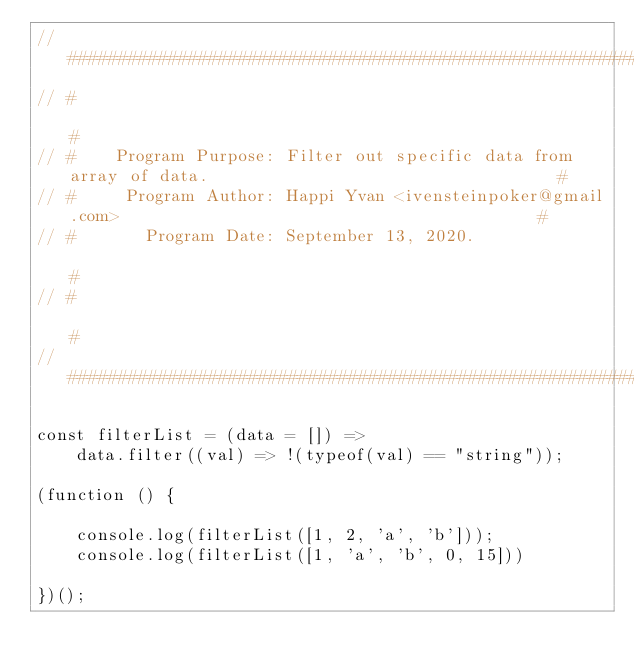Convert code to text. <code><loc_0><loc_0><loc_500><loc_500><_JavaScript_>// ######################################################################################################
// #                                                                                                    #
// #    Program Purpose: Filter out specific data from array of data.                                   #
// #     Program Author: Happi Yvan <ivensteinpoker@gmail.com>                                          #
// #       Program Date: September 13, 2020.                                                            #
// #                                                                                                    #
// ######################################################################################################

const filterList = (data = []) =>
	data.filter((val) => !(typeof(val) == "string"));

(function () {

	console.log(filterList([1, 2, 'a', 'b']));
	console.log(filterList([1, 'a', 'b', 0, 15]))

})();</code> 